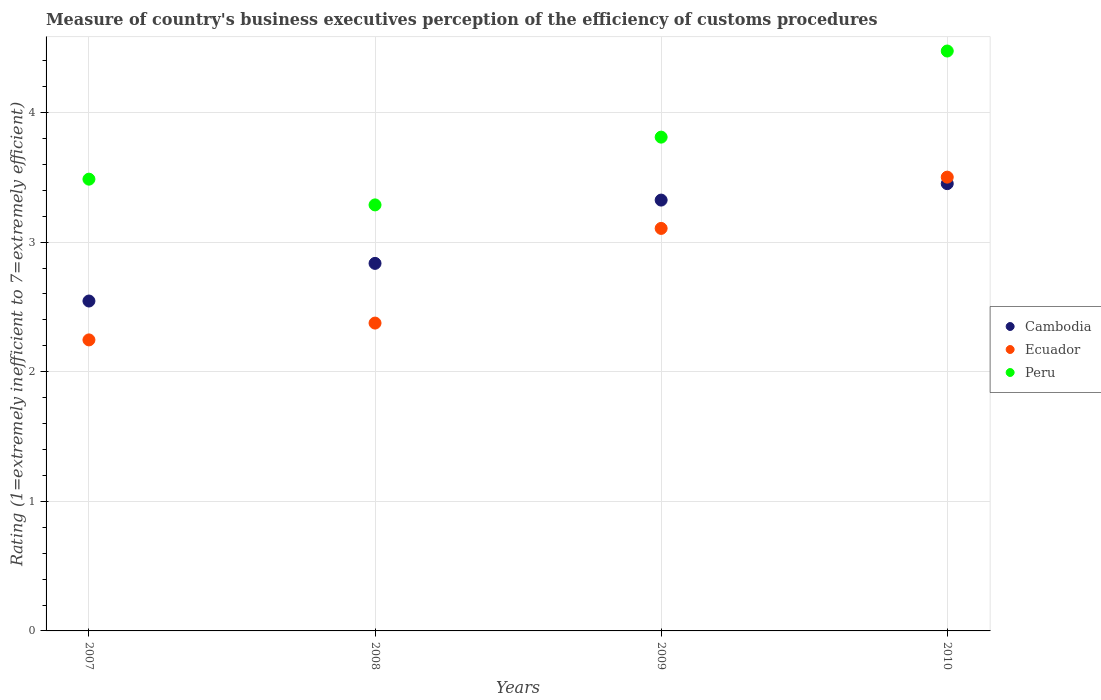How many different coloured dotlines are there?
Provide a succinct answer. 3. Is the number of dotlines equal to the number of legend labels?
Offer a terse response. Yes. What is the rating of the efficiency of customs procedure in Peru in 2008?
Offer a very short reply. 3.29. Across all years, what is the maximum rating of the efficiency of customs procedure in Peru?
Give a very brief answer. 4.47. Across all years, what is the minimum rating of the efficiency of customs procedure in Peru?
Ensure brevity in your answer.  3.29. In which year was the rating of the efficiency of customs procedure in Cambodia minimum?
Provide a short and direct response. 2007. What is the total rating of the efficiency of customs procedure in Ecuador in the graph?
Keep it short and to the point. 11.23. What is the difference between the rating of the efficiency of customs procedure in Ecuador in 2008 and that in 2009?
Make the answer very short. -0.73. What is the difference between the rating of the efficiency of customs procedure in Ecuador in 2008 and the rating of the efficiency of customs procedure in Peru in 2009?
Your response must be concise. -1.43. What is the average rating of the efficiency of customs procedure in Ecuador per year?
Keep it short and to the point. 2.81. In the year 2010, what is the difference between the rating of the efficiency of customs procedure in Ecuador and rating of the efficiency of customs procedure in Cambodia?
Ensure brevity in your answer.  0.05. What is the ratio of the rating of the efficiency of customs procedure in Cambodia in 2008 to that in 2009?
Ensure brevity in your answer.  0.85. Is the rating of the efficiency of customs procedure in Cambodia in 2008 less than that in 2010?
Give a very brief answer. Yes. Is the difference between the rating of the efficiency of customs procedure in Ecuador in 2008 and 2010 greater than the difference between the rating of the efficiency of customs procedure in Cambodia in 2008 and 2010?
Offer a terse response. No. What is the difference between the highest and the second highest rating of the efficiency of customs procedure in Cambodia?
Give a very brief answer. 0.13. What is the difference between the highest and the lowest rating of the efficiency of customs procedure in Peru?
Make the answer very short. 1.19. Is the sum of the rating of the efficiency of customs procedure in Ecuador in 2009 and 2010 greater than the maximum rating of the efficiency of customs procedure in Cambodia across all years?
Give a very brief answer. Yes. Is the rating of the efficiency of customs procedure in Cambodia strictly greater than the rating of the efficiency of customs procedure in Peru over the years?
Ensure brevity in your answer.  No. Is the rating of the efficiency of customs procedure in Ecuador strictly less than the rating of the efficiency of customs procedure in Peru over the years?
Give a very brief answer. Yes. How many dotlines are there?
Your answer should be compact. 3. How many years are there in the graph?
Provide a short and direct response. 4. What is the difference between two consecutive major ticks on the Y-axis?
Offer a very short reply. 1. Are the values on the major ticks of Y-axis written in scientific E-notation?
Keep it short and to the point. No. Does the graph contain grids?
Your answer should be very brief. Yes. Where does the legend appear in the graph?
Give a very brief answer. Center right. What is the title of the graph?
Give a very brief answer. Measure of country's business executives perception of the efficiency of customs procedures. What is the label or title of the Y-axis?
Your response must be concise. Rating (1=extremely inefficient to 7=extremely efficient). What is the Rating (1=extremely inefficient to 7=extremely efficient) of Cambodia in 2007?
Your answer should be very brief. 2.55. What is the Rating (1=extremely inefficient to 7=extremely efficient) of Ecuador in 2007?
Provide a short and direct response. 2.25. What is the Rating (1=extremely inefficient to 7=extremely efficient) in Peru in 2007?
Your answer should be compact. 3.49. What is the Rating (1=extremely inefficient to 7=extremely efficient) of Cambodia in 2008?
Keep it short and to the point. 2.84. What is the Rating (1=extremely inefficient to 7=extremely efficient) of Ecuador in 2008?
Ensure brevity in your answer.  2.38. What is the Rating (1=extremely inefficient to 7=extremely efficient) of Peru in 2008?
Provide a succinct answer. 3.29. What is the Rating (1=extremely inefficient to 7=extremely efficient) in Cambodia in 2009?
Make the answer very short. 3.32. What is the Rating (1=extremely inefficient to 7=extremely efficient) of Ecuador in 2009?
Provide a short and direct response. 3.11. What is the Rating (1=extremely inefficient to 7=extremely efficient) of Peru in 2009?
Your response must be concise. 3.81. What is the Rating (1=extremely inefficient to 7=extremely efficient) of Cambodia in 2010?
Ensure brevity in your answer.  3.45. What is the Rating (1=extremely inefficient to 7=extremely efficient) of Ecuador in 2010?
Provide a short and direct response. 3.5. What is the Rating (1=extremely inefficient to 7=extremely efficient) of Peru in 2010?
Ensure brevity in your answer.  4.47. Across all years, what is the maximum Rating (1=extremely inefficient to 7=extremely efficient) in Cambodia?
Provide a succinct answer. 3.45. Across all years, what is the maximum Rating (1=extremely inefficient to 7=extremely efficient) of Ecuador?
Your answer should be compact. 3.5. Across all years, what is the maximum Rating (1=extremely inefficient to 7=extremely efficient) in Peru?
Your response must be concise. 4.47. Across all years, what is the minimum Rating (1=extremely inefficient to 7=extremely efficient) of Cambodia?
Your answer should be compact. 2.55. Across all years, what is the minimum Rating (1=extremely inefficient to 7=extremely efficient) of Ecuador?
Your response must be concise. 2.25. Across all years, what is the minimum Rating (1=extremely inefficient to 7=extremely efficient) of Peru?
Give a very brief answer. 3.29. What is the total Rating (1=extremely inefficient to 7=extremely efficient) in Cambodia in the graph?
Your answer should be compact. 12.16. What is the total Rating (1=extremely inefficient to 7=extremely efficient) in Ecuador in the graph?
Your answer should be very brief. 11.23. What is the total Rating (1=extremely inefficient to 7=extremely efficient) of Peru in the graph?
Provide a succinct answer. 15.06. What is the difference between the Rating (1=extremely inefficient to 7=extremely efficient) in Cambodia in 2007 and that in 2008?
Ensure brevity in your answer.  -0.29. What is the difference between the Rating (1=extremely inefficient to 7=extremely efficient) in Ecuador in 2007 and that in 2008?
Your answer should be compact. -0.13. What is the difference between the Rating (1=extremely inefficient to 7=extremely efficient) of Peru in 2007 and that in 2008?
Provide a succinct answer. 0.2. What is the difference between the Rating (1=extremely inefficient to 7=extremely efficient) in Cambodia in 2007 and that in 2009?
Offer a terse response. -0.78. What is the difference between the Rating (1=extremely inefficient to 7=extremely efficient) in Ecuador in 2007 and that in 2009?
Offer a terse response. -0.86. What is the difference between the Rating (1=extremely inefficient to 7=extremely efficient) in Peru in 2007 and that in 2009?
Make the answer very short. -0.32. What is the difference between the Rating (1=extremely inefficient to 7=extremely efficient) of Cambodia in 2007 and that in 2010?
Provide a short and direct response. -0.91. What is the difference between the Rating (1=extremely inefficient to 7=extremely efficient) of Ecuador in 2007 and that in 2010?
Your response must be concise. -1.26. What is the difference between the Rating (1=extremely inefficient to 7=extremely efficient) of Peru in 2007 and that in 2010?
Ensure brevity in your answer.  -0.99. What is the difference between the Rating (1=extremely inefficient to 7=extremely efficient) of Cambodia in 2008 and that in 2009?
Ensure brevity in your answer.  -0.49. What is the difference between the Rating (1=extremely inefficient to 7=extremely efficient) in Ecuador in 2008 and that in 2009?
Make the answer very short. -0.73. What is the difference between the Rating (1=extremely inefficient to 7=extremely efficient) in Peru in 2008 and that in 2009?
Offer a very short reply. -0.52. What is the difference between the Rating (1=extremely inefficient to 7=extremely efficient) in Cambodia in 2008 and that in 2010?
Keep it short and to the point. -0.62. What is the difference between the Rating (1=extremely inefficient to 7=extremely efficient) of Ecuador in 2008 and that in 2010?
Keep it short and to the point. -1.13. What is the difference between the Rating (1=extremely inefficient to 7=extremely efficient) in Peru in 2008 and that in 2010?
Provide a succinct answer. -1.19. What is the difference between the Rating (1=extremely inefficient to 7=extremely efficient) of Cambodia in 2009 and that in 2010?
Provide a succinct answer. -0.13. What is the difference between the Rating (1=extremely inefficient to 7=extremely efficient) in Ecuador in 2009 and that in 2010?
Make the answer very short. -0.4. What is the difference between the Rating (1=extremely inefficient to 7=extremely efficient) of Peru in 2009 and that in 2010?
Your answer should be compact. -0.66. What is the difference between the Rating (1=extremely inefficient to 7=extremely efficient) in Cambodia in 2007 and the Rating (1=extremely inefficient to 7=extremely efficient) in Ecuador in 2008?
Ensure brevity in your answer.  0.17. What is the difference between the Rating (1=extremely inefficient to 7=extremely efficient) of Cambodia in 2007 and the Rating (1=extremely inefficient to 7=extremely efficient) of Peru in 2008?
Provide a short and direct response. -0.74. What is the difference between the Rating (1=extremely inefficient to 7=extremely efficient) of Ecuador in 2007 and the Rating (1=extremely inefficient to 7=extremely efficient) of Peru in 2008?
Provide a short and direct response. -1.04. What is the difference between the Rating (1=extremely inefficient to 7=extremely efficient) in Cambodia in 2007 and the Rating (1=extremely inefficient to 7=extremely efficient) in Ecuador in 2009?
Offer a terse response. -0.56. What is the difference between the Rating (1=extremely inefficient to 7=extremely efficient) of Cambodia in 2007 and the Rating (1=extremely inefficient to 7=extremely efficient) of Peru in 2009?
Provide a short and direct response. -1.26. What is the difference between the Rating (1=extremely inefficient to 7=extremely efficient) in Ecuador in 2007 and the Rating (1=extremely inefficient to 7=extremely efficient) in Peru in 2009?
Offer a terse response. -1.56. What is the difference between the Rating (1=extremely inefficient to 7=extremely efficient) in Cambodia in 2007 and the Rating (1=extremely inefficient to 7=extremely efficient) in Ecuador in 2010?
Offer a terse response. -0.96. What is the difference between the Rating (1=extremely inefficient to 7=extremely efficient) of Cambodia in 2007 and the Rating (1=extremely inefficient to 7=extremely efficient) of Peru in 2010?
Your answer should be compact. -1.93. What is the difference between the Rating (1=extremely inefficient to 7=extremely efficient) in Ecuador in 2007 and the Rating (1=extremely inefficient to 7=extremely efficient) in Peru in 2010?
Your answer should be very brief. -2.23. What is the difference between the Rating (1=extremely inefficient to 7=extremely efficient) of Cambodia in 2008 and the Rating (1=extremely inefficient to 7=extremely efficient) of Ecuador in 2009?
Offer a very short reply. -0.27. What is the difference between the Rating (1=extremely inefficient to 7=extremely efficient) in Cambodia in 2008 and the Rating (1=extremely inefficient to 7=extremely efficient) in Peru in 2009?
Give a very brief answer. -0.97. What is the difference between the Rating (1=extremely inefficient to 7=extremely efficient) in Ecuador in 2008 and the Rating (1=extremely inefficient to 7=extremely efficient) in Peru in 2009?
Your response must be concise. -1.43. What is the difference between the Rating (1=extremely inefficient to 7=extremely efficient) in Cambodia in 2008 and the Rating (1=extremely inefficient to 7=extremely efficient) in Ecuador in 2010?
Offer a terse response. -0.67. What is the difference between the Rating (1=extremely inefficient to 7=extremely efficient) of Cambodia in 2008 and the Rating (1=extremely inefficient to 7=extremely efficient) of Peru in 2010?
Make the answer very short. -1.64. What is the difference between the Rating (1=extremely inefficient to 7=extremely efficient) in Ecuador in 2008 and the Rating (1=extremely inefficient to 7=extremely efficient) in Peru in 2010?
Ensure brevity in your answer.  -2.1. What is the difference between the Rating (1=extremely inefficient to 7=extremely efficient) of Cambodia in 2009 and the Rating (1=extremely inefficient to 7=extremely efficient) of Ecuador in 2010?
Your answer should be very brief. -0.18. What is the difference between the Rating (1=extremely inefficient to 7=extremely efficient) of Cambodia in 2009 and the Rating (1=extremely inefficient to 7=extremely efficient) of Peru in 2010?
Your answer should be very brief. -1.15. What is the difference between the Rating (1=extremely inefficient to 7=extremely efficient) of Ecuador in 2009 and the Rating (1=extremely inefficient to 7=extremely efficient) of Peru in 2010?
Your answer should be compact. -1.37. What is the average Rating (1=extremely inefficient to 7=extremely efficient) in Cambodia per year?
Offer a very short reply. 3.04. What is the average Rating (1=extremely inefficient to 7=extremely efficient) in Ecuador per year?
Your response must be concise. 2.81. What is the average Rating (1=extremely inefficient to 7=extremely efficient) of Peru per year?
Ensure brevity in your answer.  3.76. In the year 2007, what is the difference between the Rating (1=extremely inefficient to 7=extremely efficient) of Cambodia and Rating (1=extremely inefficient to 7=extremely efficient) of Peru?
Your response must be concise. -0.94. In the year 2007, what is the difference between the Rating (1=extremely inefficient to 7=extremely efficient) of Ecuador and Rating (1=extremely inefficient to 7=extremely efficient) of Peru?
Give a very brief answer. -1.24. In the year 2008, what is the difference between the Rating (1=extremely inefficient to 7=extremely efficient) of Cambodia and Rating (1=extremely inefficient to 7=extremely efficient) of Ecuador?
Your answer should be compact. 0.46. In the year 2008, what is the difference between the Rating (1=extremely inefficient to 7=extremely efficient) in Cambodia and Rating (1=extremely inefficient to 7=extremely efficient) in Peru?
Ensure brevity in your answer.  -0.45. In the year 2008, what is the difference between the Rating (1=extremely inefficient to 7=extremely efficient) in Ecuador and Rating (1=extremely inefficient to 7=extremely efficient) in Peru?
Offer a terse response. -0.91. In the year 2009, what is the difference between the Rating (1=extremely inefficient to 7=extremely efficient) of Cambodia and Rating (1=extremely inefficient to 7=extremely efficient) of Ecuador?
Offer a very short reply. 0.22. In the year 2009, what is the difference between the Rating (1=extremely inefficient to 7=extremely efficient) in Cambodia and Rating (1=extremely inefficient to 7=extremely efficient) in Peru?
Provide a succinct answer. -0.49. In the year 2009, what is the difference between the Rating (1=extremely inefficient to 7=extremely efficient) of Ecuador and Rating (1=extremely inefficient to 7=extremely efficient) of Peru?
Your response must be concise. -0.7. In the year 2010, what is the difference between the Rating (1=extremely inefficient to 7=extremely efficient) of Cambodia and Rating (1=extremely inefficient to 7=extremely efficient) of Ecuador?
Make the answer very short. -0.05. In the year 2010, what is the difference between the Rating (1=extremely inefficient to 7=extremely efficient) of Cambodia and Rating (1=extremely inefficient to 7=extremely efficient) of Peru?
Provide a short and direct response. -1.02. In the year 2010, what is the difference between the Rating (1=extremely inefficient to 7=extremely efficient) of Ecuador and Rating (1=extremely inefficient to 7=extremely efficient) of Peru?
Provide a succinct answer. -0.97. What is the ratio of the Rating (1=extremely inefficient to 7=extremely efficient) of Cambodia in 2007 to that in 2008?
Your response must be concise. 0.9. What is the ratio of the Rating (1=extremely inefficient to 7=extremely efficient) of Ecuador in 2007 to that in 2008?
Offer a very short reply. 0.95. What is the ratio of the Rating (1=extremely inefficient to 7=extremely efficient) in Peru in 2007 to that in 2008?
Offer a very short reply. 1.06. What is the ratio of the Rating (1=extremely inefficient to 7=extremely efficient) in Cambodia in 2007 to that in 2009?
Offer a very short reply. 0.77. What is the ratio of the Rating (1=extremely inefficient to 7=extremely efficient) of Ecuador in 2007 to that in 2009?
Your response must be concise. 0.72. What is the ratio of the Rating (1=extremely inefficient to 7=extremely efficient) of Peru in 2007 to that in 2009?
Your answer should be compact. 0.91. What is the ratio of the Rating (1=extremely inefficient to 7=extremely efficient) of Cambodia in 2007 to that in 2010?
Make the answer very short. 0.74. What is the ratio of the Rating (1=extremely inefficient to 7=extremely efficient) of Ecuador in 2007 to that in 2010?
Give a very brief answer. 0.64. What is the ratio of the Rating (1=extremely inefficient to 7=extremely efficient) in Peru in 2007 to that in 2010?
Offer a very short reply. 0.78. What is the ratio of the Rating (1=extremely inefficient to 7=extremely efficient) in Cambodia in 2008 to that in 2009?
Ensure brevity in your answer.  0.85. What is the ratio of the Rating (1=extremely inefficient to 7=extremely efficient) of Ecuador in 2008 to that in 2009?
Make the answer very short. 0.76. What is the ratio of the Rating (1=extremely inefficient to 7=extremely efficient) in Peru in 2008 to that in 2009?
Ensure brevity in your answer.  0.86. What is the ratio of the Rating (1=extremely inefficient to 7=extremely efficient) of Cambodia in 2008 to that in 2010?
Give a very brief answer. 0.82. What is the ratio of the Rating (1=extremely inefficient to 7=extremely efficient) in Ecuador in 2008 to that in 2010?
Make the answer very short. 0.68. What is the ratio of the Rating (1=extremely inefficient to 7=extremely efficient) of Peru in 2008 to that in 2010?
Offer a very short reply. 0.73. What is the ratio of the Rating (1=extremely inefficient to 7=extremely efficient) of Cambodia in 2009 to that in 2010?
Offer a very short reply. 0.96. What is the ratio of the Rating (1=extremely inefficient to 7=extremely efficient) of Ecuador in 2009 to that in 2010?
Keep it short and to the point. 0.89. What is the ratio of the Rating (1=extremely inefficient to 7=extremely efficient) in Peru in 2009 to that in 2010?
Offer a very short reply. 0.85. What is the difference between the highest and the second highest Rating (1=extremely inefficient to 7=extremely efficient) of Cambodia?
Keep it short and to the point. 0.13. What is the difference between the highest and the second highest Rating (1=extremely inefficient to 7=extremely efficient) in Ecuador?
Provide a short and direct response. 0.4. What is the difference between the highest and the second highest Rating (1=extremely inefficient to 7=extremely efficient) in Peru?
Offer a very short reply. 0.66. What is the difference between the highest and the lowest Rating (1=extremely inefficient to 7=extremely efficient) of Cambodia?
Your answer should be very brief. 0.91. What is the difference between the highest and the lowest Rating (1=extremely inefficient to 7=extremely efficient) of Ecuador?
Provide a succinct answer. 1.26. What is the difference between the highest and the lowest Rating (1=extremely inefficient to 7=extremely efficient) of Peru?
Provide a short and direct response. 1.19. 